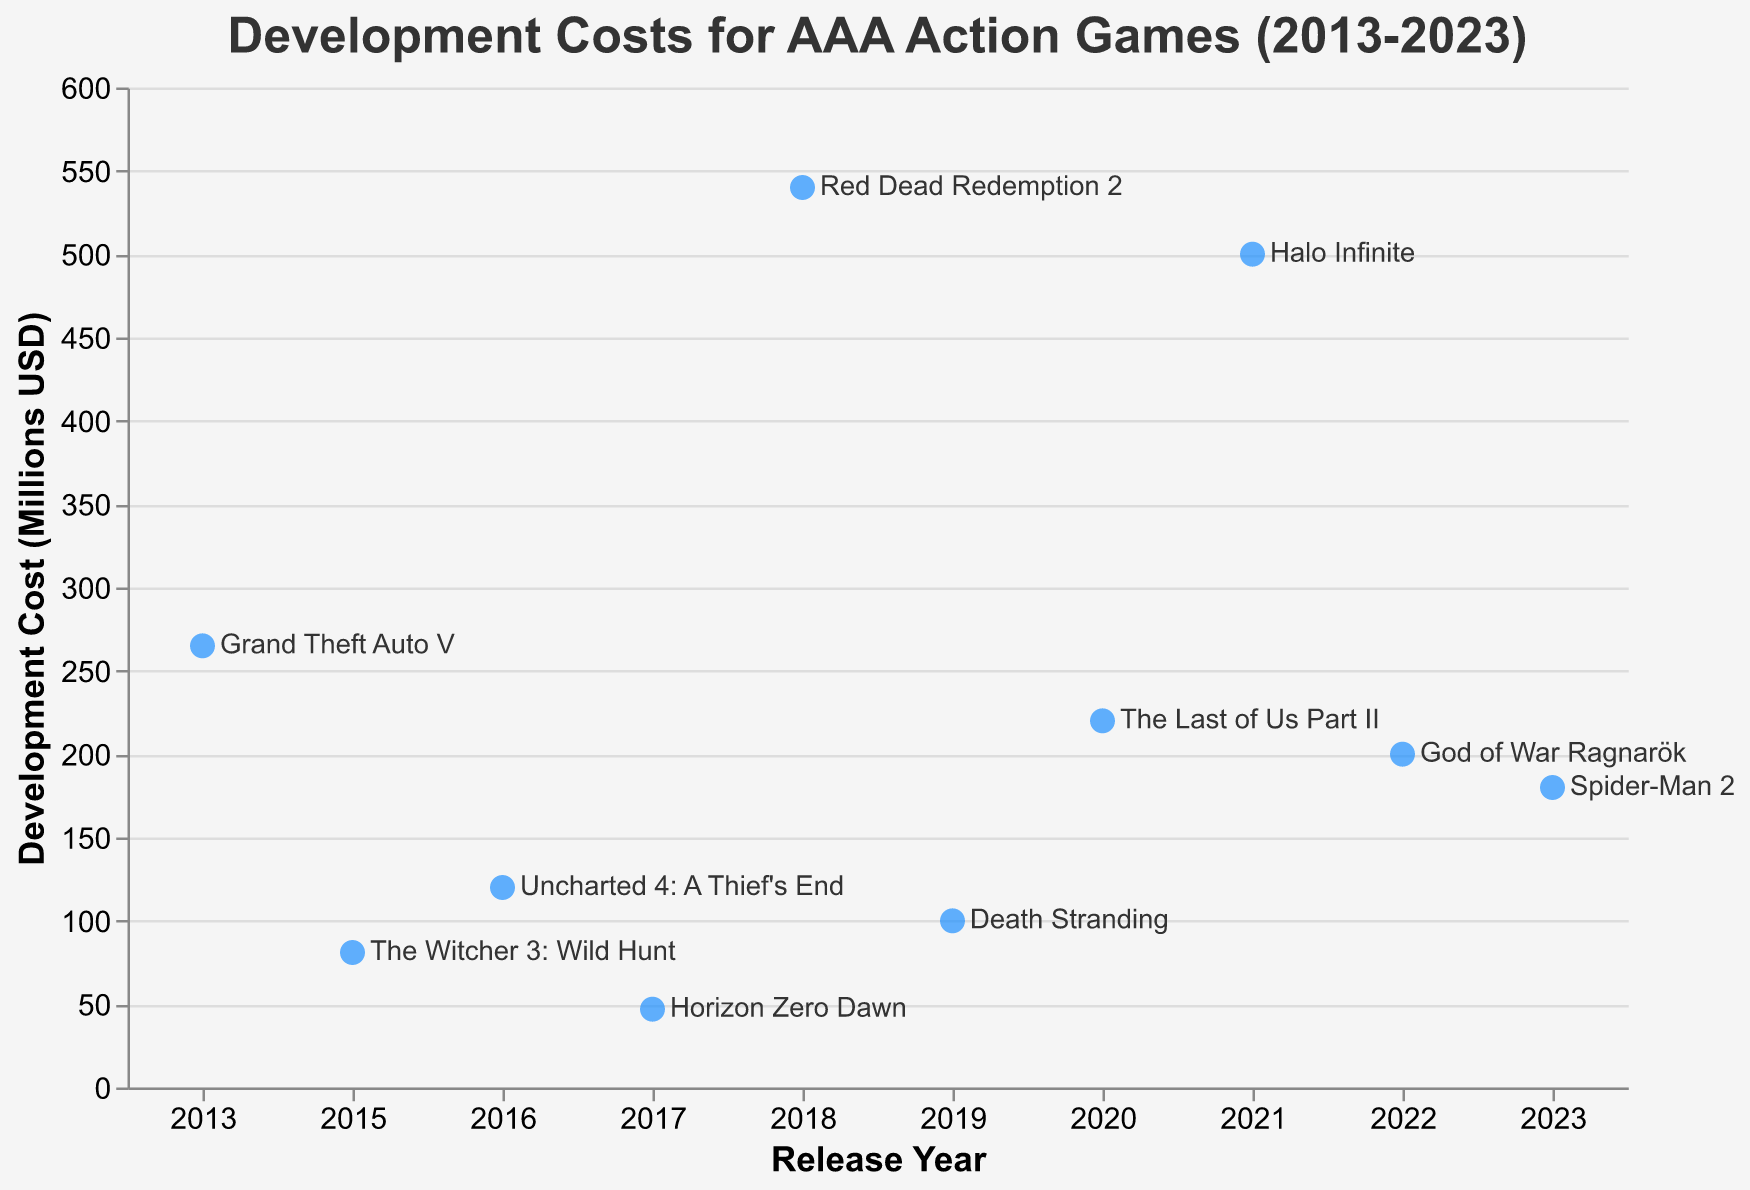What is the title of the figure? The title is usually found at the top of the figure, indicating what the plot shows. In this case, it mentions the subject of the plot in plain text.
Answer: Development Costs for AAA Action Games (2013-2023) What year had the highest development cost, and what game was it? To answer this, look for the data point positioned at the highest y-axis value and read its corresponding year and game label.
Answer: 2018, Red Dead Redemption 2 How many games had a development cost above 200 million USD? Count the number of data points whose y-axis value (Development Cost) exceeds 200.
Answer: 4 What is the range of development costs shown in the plot? The range is the difference between the highest and lowest values on the y-axis (Development Cost). The highest is 540, and the lowest is 47. Subtract the lowest from the highest value.
Answer: 493 million USD Which game in 2020 had a high development cost, and what was the cost? Identify the data point for the year 2020 and read the game name and its corresponding development cost.
Answer: The Last of Us Part II, 220 million USD What's the average development cost of the games listed? Sum all the development costs and divide by the number of games. Calculation: (265 + 81 + 120 + 47 + 540 + 100 + 220 + 500 + 200 + 180) / 10.
Answer: 225.3 million USD How does the development cost of God of War Ragnarök compare to Halo Infinite? Check the development costs of both games and compare their values. God of War Ragnarök has a cost of 200, and Halo Infinite has 500.
Answer: Halo Infinite had a higher development cost How has the development cost trend changed over the decade? Observe the general direction of the data points over the years; check if the costs increase, decrease, or remain constant.
Answer: Increasing overall Which year had the minimum development cost, and what game was it? Identify the year with the lowest data point on the y-axis and read the game label.
Answer: 2017, Horizon Zero Dawn What is the median development cost of the listed games? Arrange the development costs in ascending order and find the middle value. If the number of data points is even, the median is the average of the two central values. For 10 points: (47, 81, 100, 120, 180, 200, 220, 265, 500, 540), the median is the average of 180 and 200.
Answer: 190 million USD 